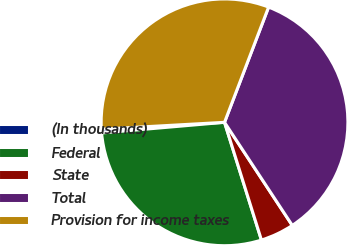Convert chart. <chart><loc_0><loc_0><loc_500><loc_500><pie_chart><fcel>(In thousands)<fcel>Federal<fcel>State<fcel>Total<fcel>Provision for income taxes<nl><fcel>0.49%<fcel>28.46%<fcel>4.42%<fcel>34.93%<fcel>31.7%<nl></chart> 